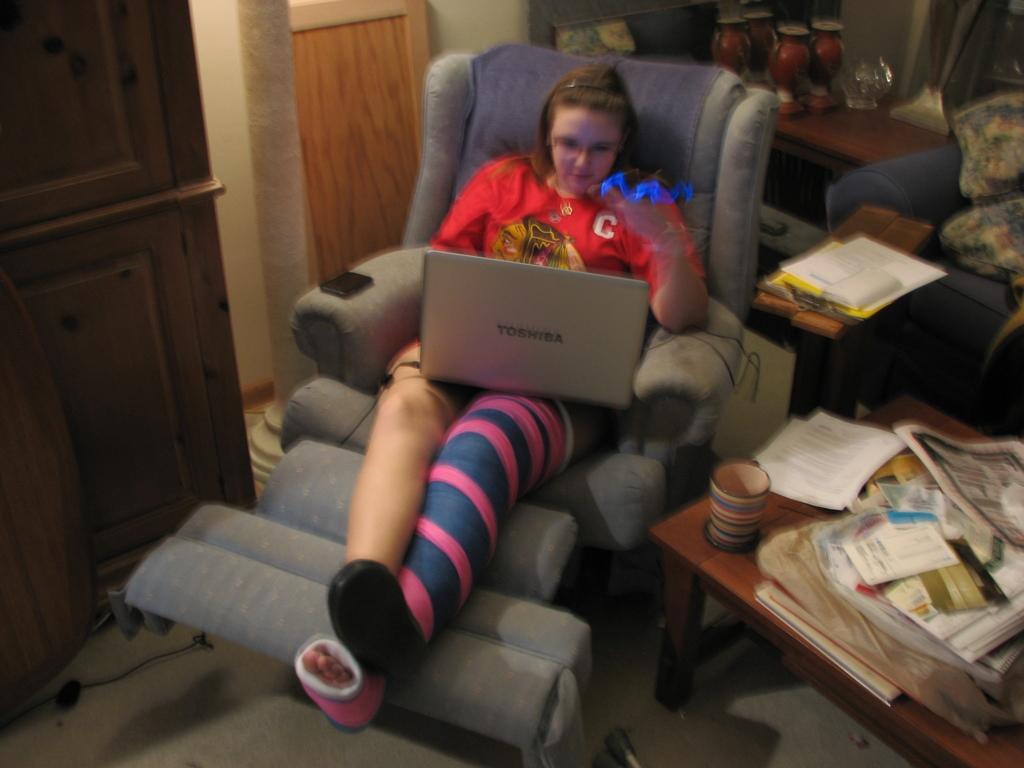Can you describe this image briefly? This image is taken indoors. At the bottom of the image there is a floor. In the middle of the image a woman is sitting on the resting chair and there is a laptop on her laps. On the right side of the image there is a table with many books, papers and a cup on it and there is a couch with pillows and books. On the left side of the image there is a door. In the background there is a wall and there are a few things on the table. 